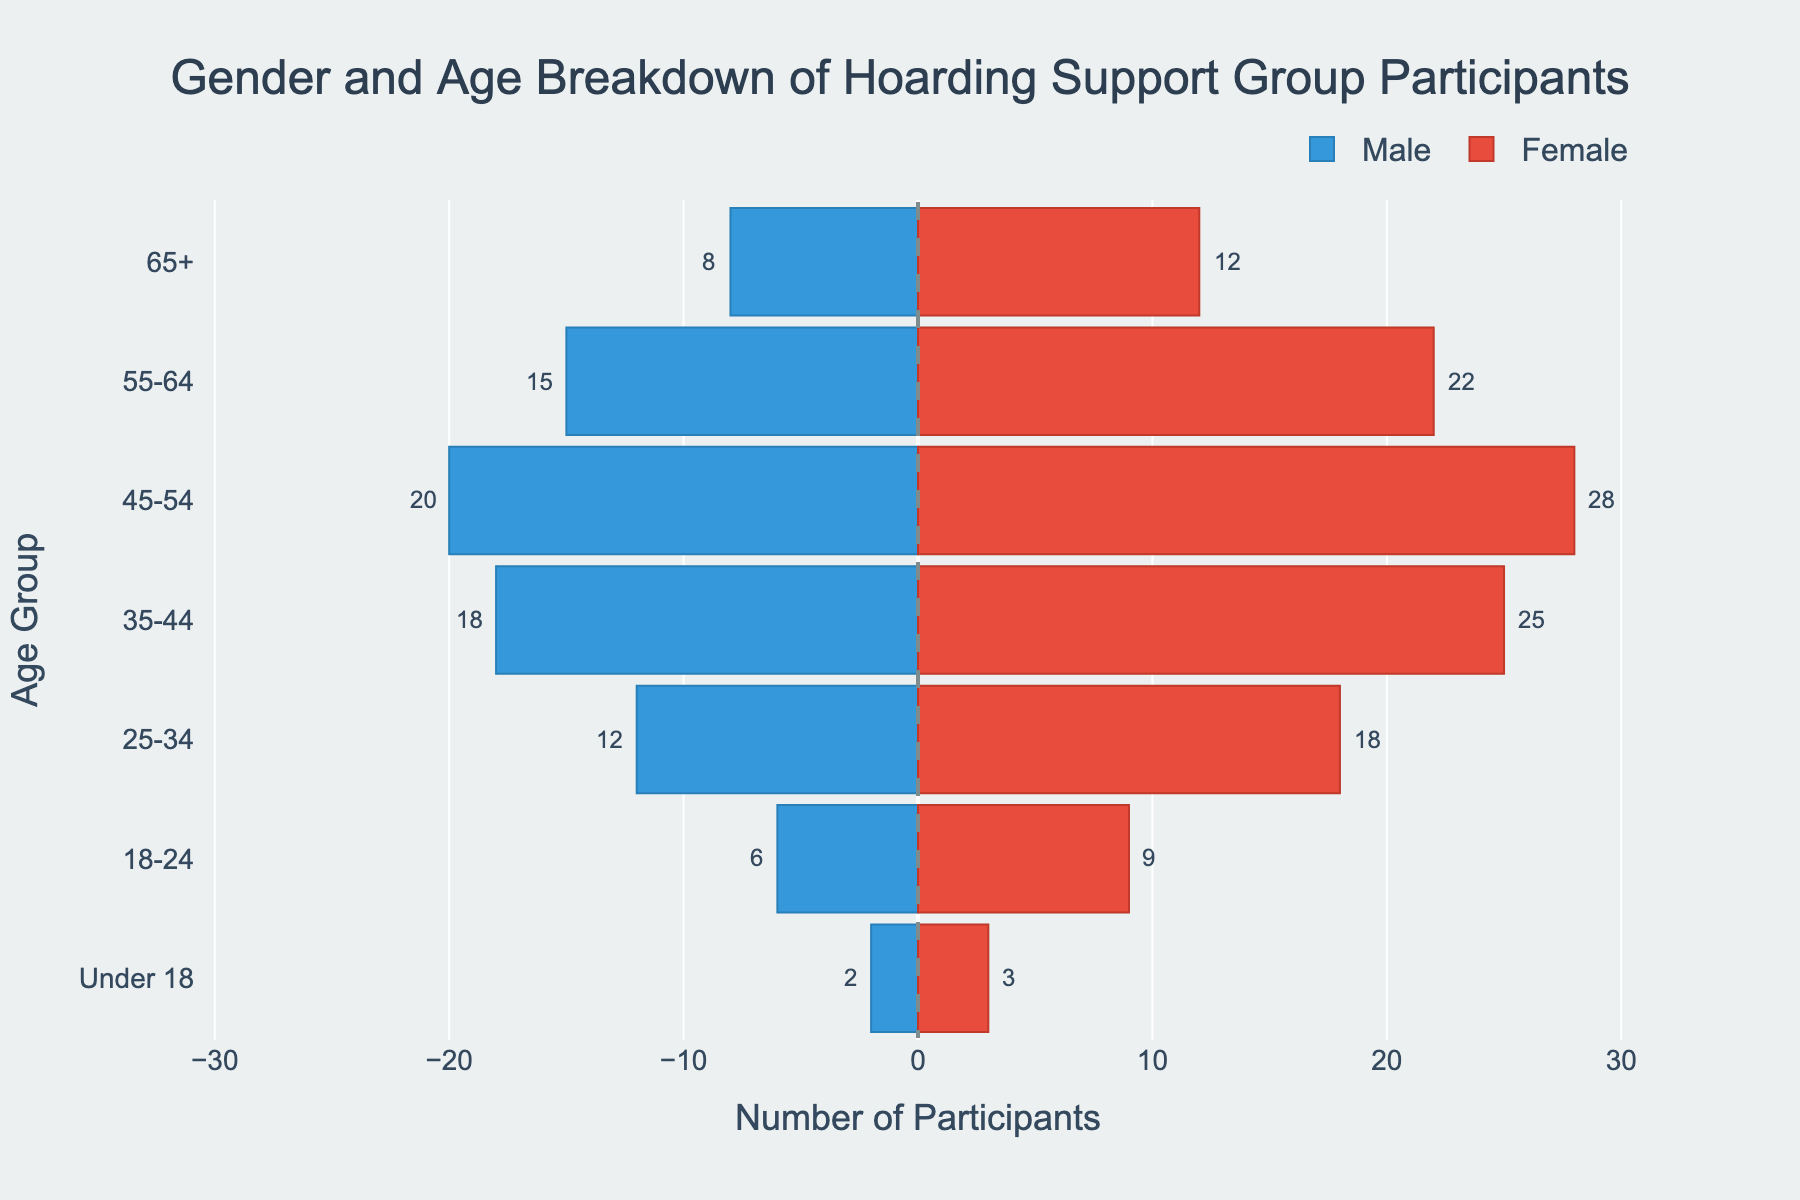What's the title of the figure? The title is displayed at the top center of the figure. It reads "Gender and Age Breakdown of Hoarding Support Group Participants".
Answer: Gender and Age Breakdown of Hoarding Support Group Participants Which age group has the highest number of female participants? Look at the bars corresponding to female participants and identify the age group with the longest bar. The age group "45-54" has the longest bar for females with 28 participants.
Answer: 45-54 How many male participants are in the 55-64 age group? The bar to the left of the zero line represents males. The bar corresponding to the age group "55-64" for males is labeled with a value of 15.
Answer: 15 In the "18-24" age group, how does the number of male participants compare to the number of female participants? Compare the lengths of the bars for males (6) and females (9) in the "18-24" age group. There are fewer male participants (6) than female participants (9).
Answer: There are fewer male participants than female participants What is the total number of participants in the "35-44" age group? Sum the number of male (18) and female (25) participants in this age group: 18 (males) + 25 (females) = 43.
Answer: 43 Which gender has more participants in the "65+" age group, and by how many? Compare the number of male (8) and female (12) participants in the "65+" age group. Females have 12 participants, which is 4 more than males who have 8 participants: 12 - 8 = 4.
Answer: Females by 4 What is the difference in the total number of participants between age groups "25-34" and "45-54"? Calculate the total participants for "25-34" (12 males + 18 females = 30) and "45-54" (20 males + 28 females = 48). The difference is 48 - 30 = 18.
Answer: 18 Which age group has the smallest number of total participants, and how many are there? Calculate the total participants in each age group and compare. "Under 18" has the smallest number: 2 males + 3 females = 5.
Answer: Under 18, 5 What is the average number of female participants across all age groups? Sum the female participants and divide by the number of age groups. (12 + 22 + 28 + 25 + 18 + 9 + 3) / 7 = 117 / 7 ≈ 16.71.
Answer: Approximately 16.71 How do the numbers of male and female participants compare in the "45-54" age group? The "45-54" age group has 20 male participants and 28 female participants. Females outnumber males by 8 participants: 28 - 20 = 8.
Answer: Females outnumber males by 8 